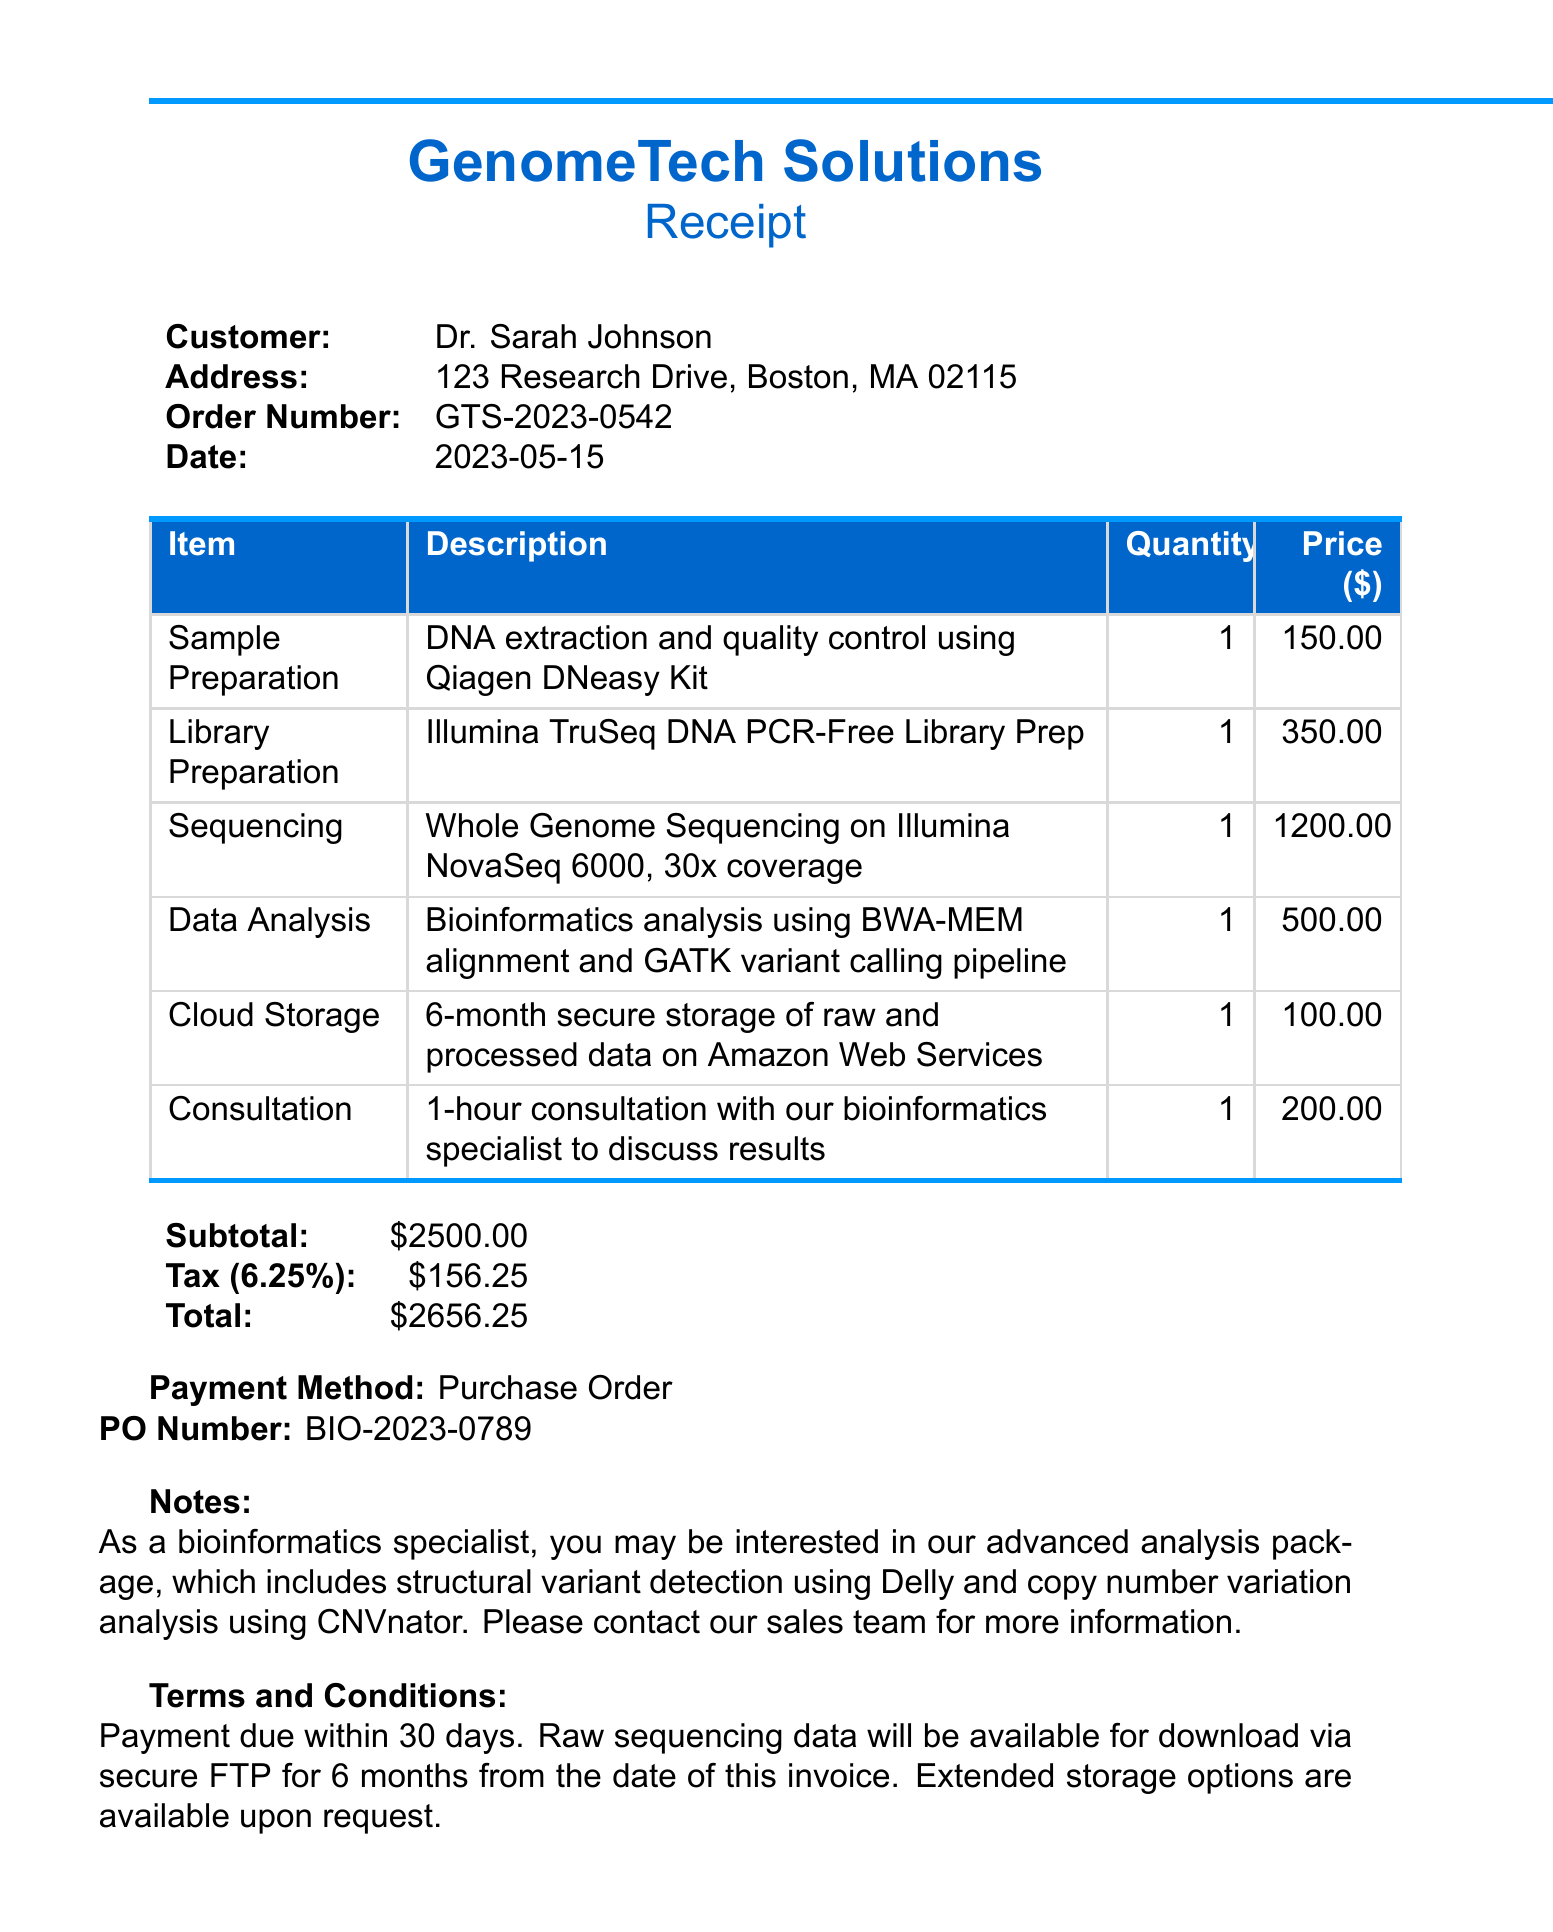What is the company name? The company name is listed at the top of the document as the provider of the service.
Answer: GenomeTech Solutions What is the order number? The order number can be found in the customer details section of the document to identify the specific transaction.
Answer: GTS-2023-0542 What item had the highest unit price? To determine this, we compare the unit prices of each listed item in the receipt.
Answer: Sequencing What is the subtotal amount? The subtotal amount is specified in the financial summary section of the document before tax is applied.
Answer: $2500.00 What is the total amount after tax? The total amount is the sum of the subtotal and tax amount, as presented in the financial summary section.
Answer: $2656.25 What was the payment method? The document explicitly states the payment method used for this transaction.
Answer: Purchase Order How long is the cloud storage included? The details about cloud storage duration are specifically mentioned in the item description of the service.
Answer: 6-month What is the tax rate applied? The tax rate is mentioned in the financial summary section and indicates the percentage used to calculate tax.
Answer: 6.25% What is stated under notes? The notes section contains additional information and offers related to the services provided.
Answer: As a bioinformatics specialist, you may be interested in our advanced analysis package, which includes structural variant detection using Delly and copy number variation analysis using CNVnator. Please contact our sales team for more information 